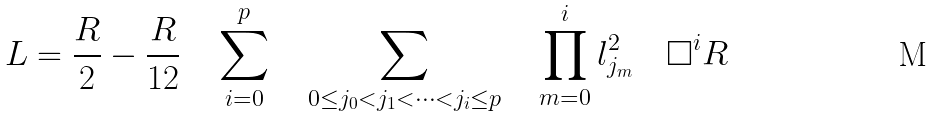<formula> <loc_0><loc_0><loc_500><loc_500>L = \frac { R } { 2 } - \frac { R } { 1 2 } \quad \sum ^ { p } _ { i = 0 } \quad \sum _ { 0 \leq j _ { 0 } < j _ { 1 } < \dots < j _ { i } \leq p } \quad \prod ^ { i } _ { m = 0 } l ^ { 2 } _ { j _ { m } } \quad \Box ^ { i } R</formula> 